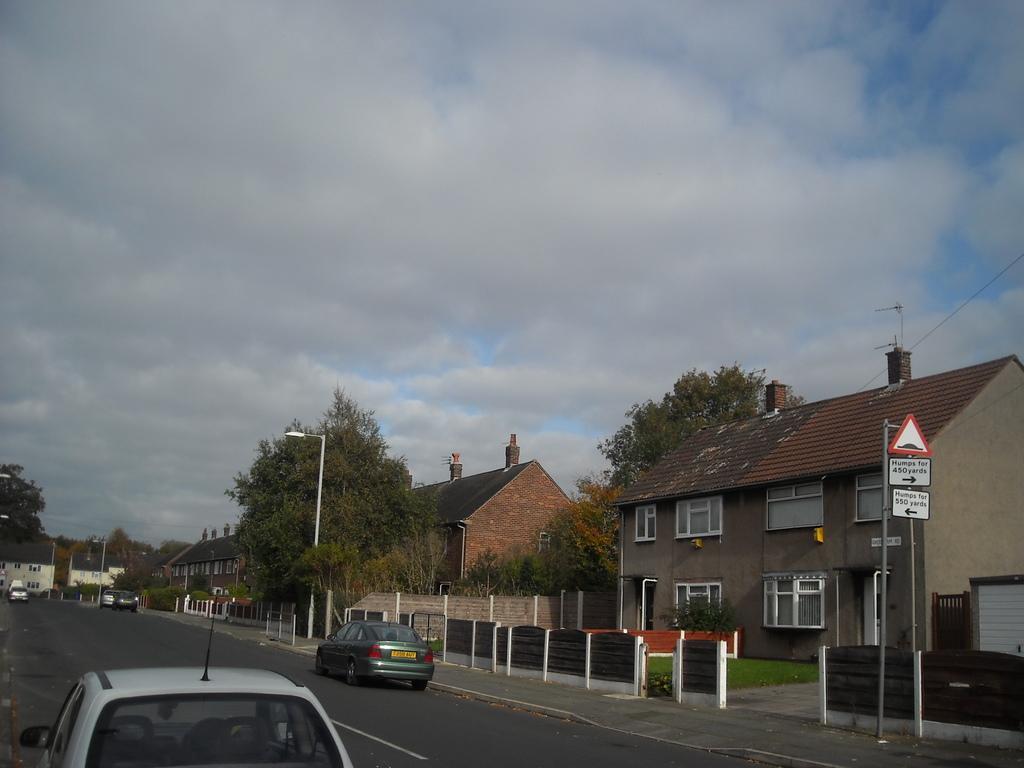Please provide a concise description of this image. In this image I can see the vehicles on the road. To the side of the road I can see the poles, boards and the railing. I can see many trees and the houses with windows. I can also see many trees, clouds and the sky. 